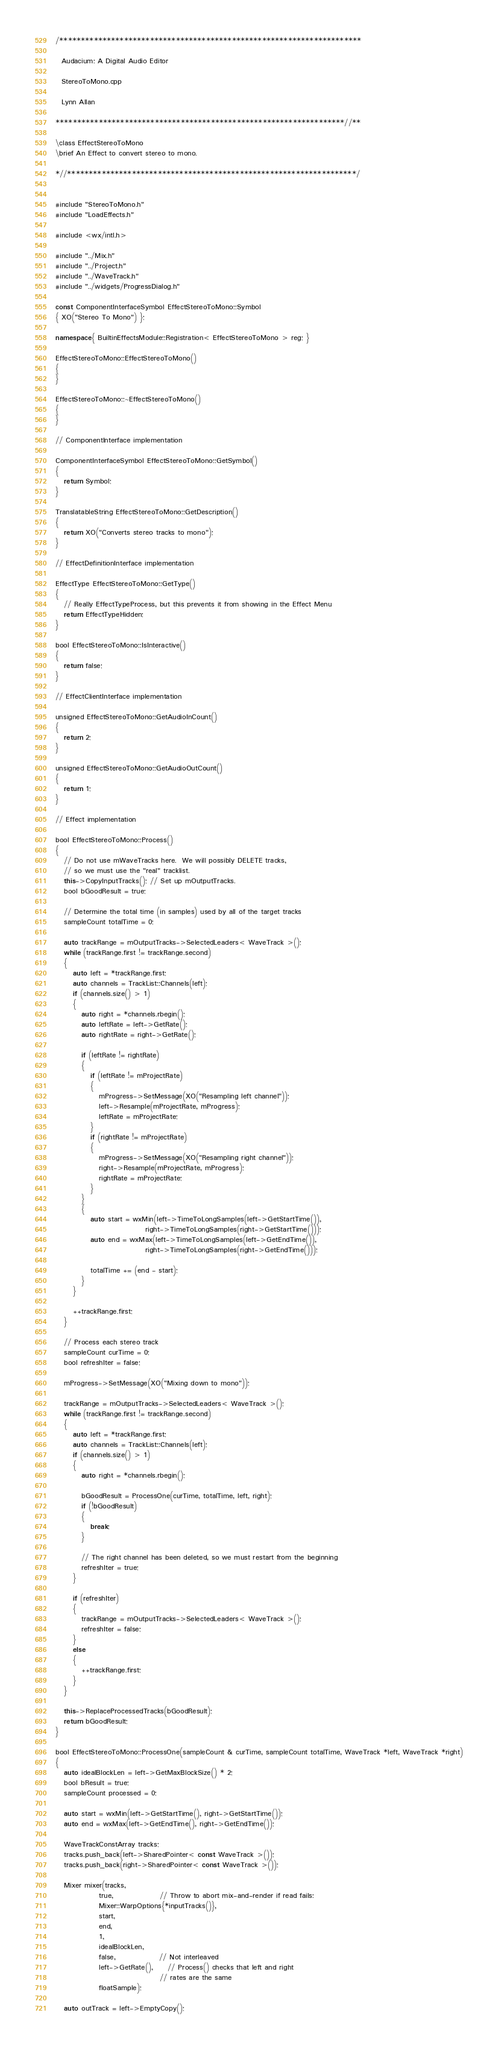Convert code to text. <code><loc_0><loc_0><loc_500><loc_500><_C++_>/**********************************************************************

  Audacium: A Digital Audio Editor

  StereoToMono.cpp

  Lynn Allan

*******************************************************************//**

\class EffectStereoToMono
\brief An Effect to convert stereo to mono.

*//*******************************************************************/


#include "StereoToMono.h"
#include "LoadEffects.h"

#include <wx/intl.h>

#include "../Mix.h"
#include "../Project.h"
#include "../WaveTrack.h"
#include "../widgets/ProgressDialog.h"

const ComponentInterfaceSymbol EffectStereoToMono::Symbol
{ XO("Stereo To Mono") };

namespace{ BuiltinEffectsModule::Registration< EffectStereoToMono > reg; }

EffectStereoToMono::EffectStereoToMono()
{
}

EffectStereoToMono::~EffectStereoToMono()
{
}

// ComponentInterface implementation

ComponentInterfaceSymbol EffectStereoToMono::GetSymbol()
{
   return Symbol;
}

TranslatableString EffectStereoToMono::GetDescription()
{
   return XO("Converts stereo tracks to mono");
}

// EffectDefinitionInterface implementation

EffectType EffectStereoToMono::GetType()
{
   // Really EffectTypeProcess, but this prevents it from showing in the Effect Menu
   return EffectTypeHidden;
}

bool EffectStereoToMono::IsInteractive()
{
   return false;
}

// EffectClientInterface implementation

unsigned EffectStereoToMono::GetAudioInCount()
{
   return 2;
}

unsigned EffectStereoToMono::GetAudioOutCount()
{
   return 1;
}

// Effect implementation

bool EffectStereoToMono::Process()
{
   // Do not use mWaveTracks here.  We will possibly DELETE tracks,
   // so we must use the "real" tracklist.
   this->CopyInputTracks(); // Set up mOutputTracks.
   bool bGoodResult = true;

   // Determine the total time (in samples) used by all of the target tracks
   sampleCount totalTime = 0;
   
   auto trackRange = mOutputTracks->SelectedLeaders< WaveTrack >();
   while (trackRange.first != trackRange.second)
   {
      auto left = *trackRange.first;
      auto channels = TrackList::Channels(left);
      if (channels.size() > 1)
      {
         auto right = *channels.rbegin();
         auto leftRate = left->GetRate();
         auto rightRate = right->GetRate();

         if (leftRate != rightRate)
         {
            if (leftRate != mProjectRate)
            {
               mProgress->SetMessage(XO("Resampling left channel"));
               left->Resample(mProjectRate, mProgress);
               leftRate = mProjectRate;
            }
            if (rightRate != mProjectRate)
            {
               mProgress->SetMessage(XO("Resampling right channel"));
               right->Resample(mProjectRate, mProgress);
               rightRate = mProjectRate;
            }
         }
         {
            auto start = wxMin(left->TimeToLongSamples(left->GetStartTime()),
                               right->TimeToLongSamples(right->GetStartTime()));
            auto end = wxMax(left->TimeToLongSamples(left->GetEndTime()),
                               right->TimeToLongSamples(right->GetEndTime()));

            totalTime += (end - start);
         }
      }

      ++trackRange.first;
   }

   // Process each stereo track
   sampleCount curTime = 0;
   bool refreshIter = false;

   mProgress->SetMessage(XO("Mixing down to mono"));

   trackRange = mOutputTracks->SelectedLeaders< WaveTrack >();
   while (trackRange.first != trackRange.second)
   {
      auto left = *trackRange.first;
      auto channels = TrackList::Channels(left);
      if (channels.size() > 1)
      {
         auto right = *channels.rbegin();

         bGoodResult = ProcessOne(curTime, totalTime, left, right);
         if (!bGoodResult)
         {
            break;
         }

         // The right channel has been deleted, so we must restart from the beginning
         refreshIter = true;
      }

      if (refreshIter)
      {
         trackRange = mOutputTracks->SelectedLeaders< WaveTrack >();
         refreshIter = false;
      }
      else
      {
         ++trackRange.first;
      }
   }

   this->ReplaceProcessedTracks(bGoodResult);
   return bGoodResult;
}

bool EffectStereoToMono::ProcessOne(sampleCount & curTime, sampleCount totalTime, WaveTrack *left, WaveTrack *right)
{
   auto idealBlockLen = left->GetMaxBlockSize() * 2;
   bool bResult = true;
   sampleCount processed = 0;

   auto start = wxMin(left->GetStartTime(), right->GetStartTime());
   auto end = wxMax(left->GetEndTime(), right->GetEndTime());

   WaveTrackConstArray tracks;
   tracks.push_back(left->SharedPointer< const WaveTrack >());
   tracks.push_back(right->SharedPointer< const WaveTrack >());

   Mixer mixer(tracks,
               true,                // Throw to abort mix-and-render if read fails:
               Mixer::WarpOptions{*inputTracks()},
               start,
               end,
               1,
               idealBlockLen,
               false,               // Not interleaved
               left->GetRate(),     // Process() checks that left and right
                                    // rates are the same
               floatSample);

   auto outTrack = left->EmptyCopy();</code> 